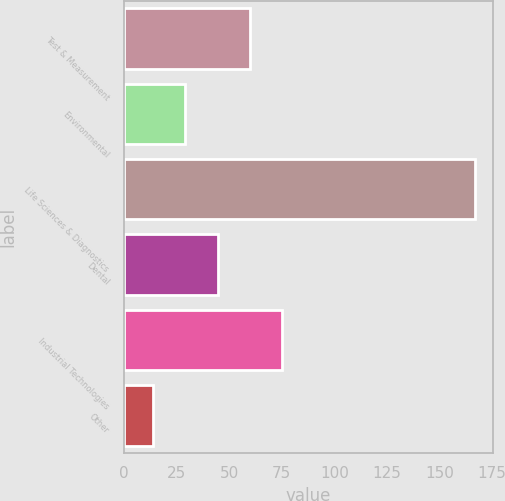<chart> <loc_0><loc_0><loc_500><loc_500><bar_chart><fcel>Test & Measurement<fcel>Environmental<fcel>Life Sciences & Diagnostics<fcel>Dental<fcel>Industrial Technologies<fcel>Other<nl><fcel>59.9<fcel>29.3<fcel>167<fcel>44.6<fcel>75.2<fcel>14<nl></chart> 